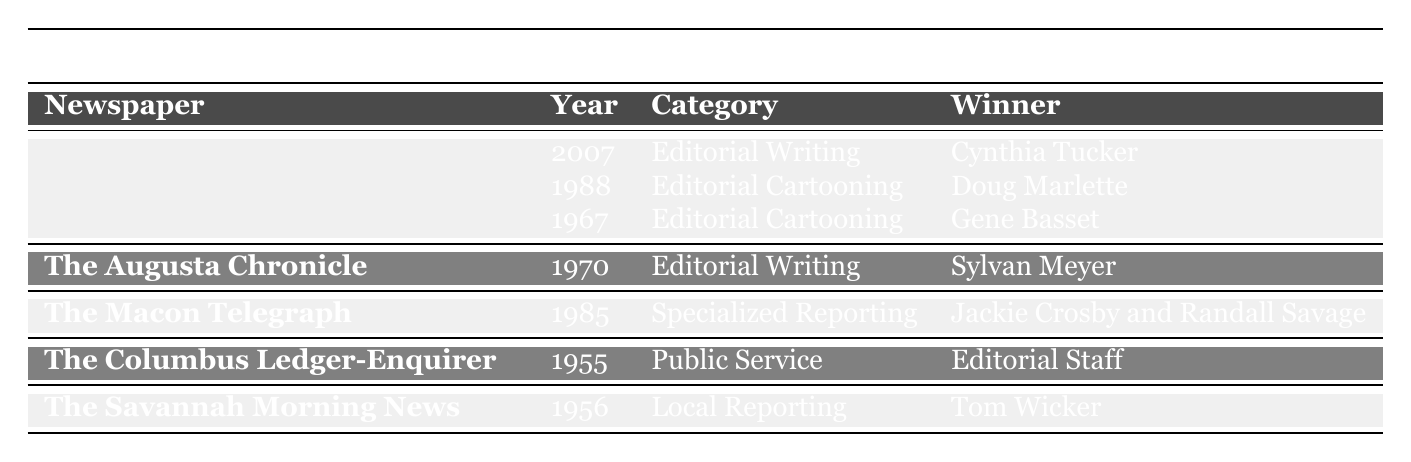What newspaper won the Pulitzer Prize for Editorial Writing in 2007? The table lists the winners by category and year. Under "The Atlanta Journal-Constitution," the year 2007 has an entry for Editorial Writing, which shows Cynthia Tucker as the winner.
Answer: The Atlanta Journal-Constitution How many Pulitzer Prizes did The Atlanta Journal-Constitution win between 1950 and 2020? The table shows three entries for The Atlanta Journal-Constitution, indicating it won three Pulitzer Prizes within the specified timeframe.
Answer: Three Did The Macon Telegraph win a Pulitzer Prize for Local Reporting? The table indicates that The Macon Telegraph won a Pulitzer Prize in 1985 for Specialized Reporting, but there is no entry for Local Reporting. Therefore, the answer is no.
Answer: No Which category had the earliest Pulitzer Prize awarded in Georgia newspapers? The table presents the years associated with each prize. The earliest year listed is 1955 for Public Service awarded to the Editorial Staff of The Columbus Ledger-Enquirer. This means Public Service is the category with the earliest award in Georgia newspapers.
Answer: Public Service Which newspaper has more Pulitzer Prize winners, The Atlanta Journal-Constitution or The Augusta Chronicle? The Atlanta Journal-Constitution has three winners, while The Augusta Chronicle has one winner. Therefore, The Atlanta Journal-Constitution has more winners.
Answer: The Atlanta Journal-Constitution Which winner from The Savannah Morning News was awarded the Pulitzer Prize? The table shows that Tom Wicker won the Pulitzer Prize for Local Reporting in 1956, indicating he is the winner from The Savannah Morning News.
Answer: Tom Wicker In what year did The Columbus Ledger-Enquirer win the Pulitzer Prize and in what category? The table notes that The Columbus Ledger-Enquirer won the Pulitzer Prize in 1955 for Public Service. This is the relevant year and category.
Answer: 1955, Public Service Are there any winners from 1988 in the table? Yes, the table lists Doug Marlette as the winner for Editorial Cartooning in 1988 under The Atlanta Journal-Constitution. This confirms the presence of a winner from that year.
Answer: Yes What is the total number of Pulitzer Prizes won by Georgia newspapers listed in the table? By counting the prizes: The Atlanta Journal-Constitution (3), The Augusta Chronicle (1), The Macon Telegraph (1), The Columbus Ledger-Enquirer (1), and The Savannah Morning News (1), we get a total of 7 prizes.
Answer: Seven Which winner was a team from The Macon Telegraph? The table states that Jackie Crosby and Randall Savage won for Specialized Reporting in 1985, indicating they were a team from The Macon Telegraph.
Answer: Jackie Crosby and Randall Savage 